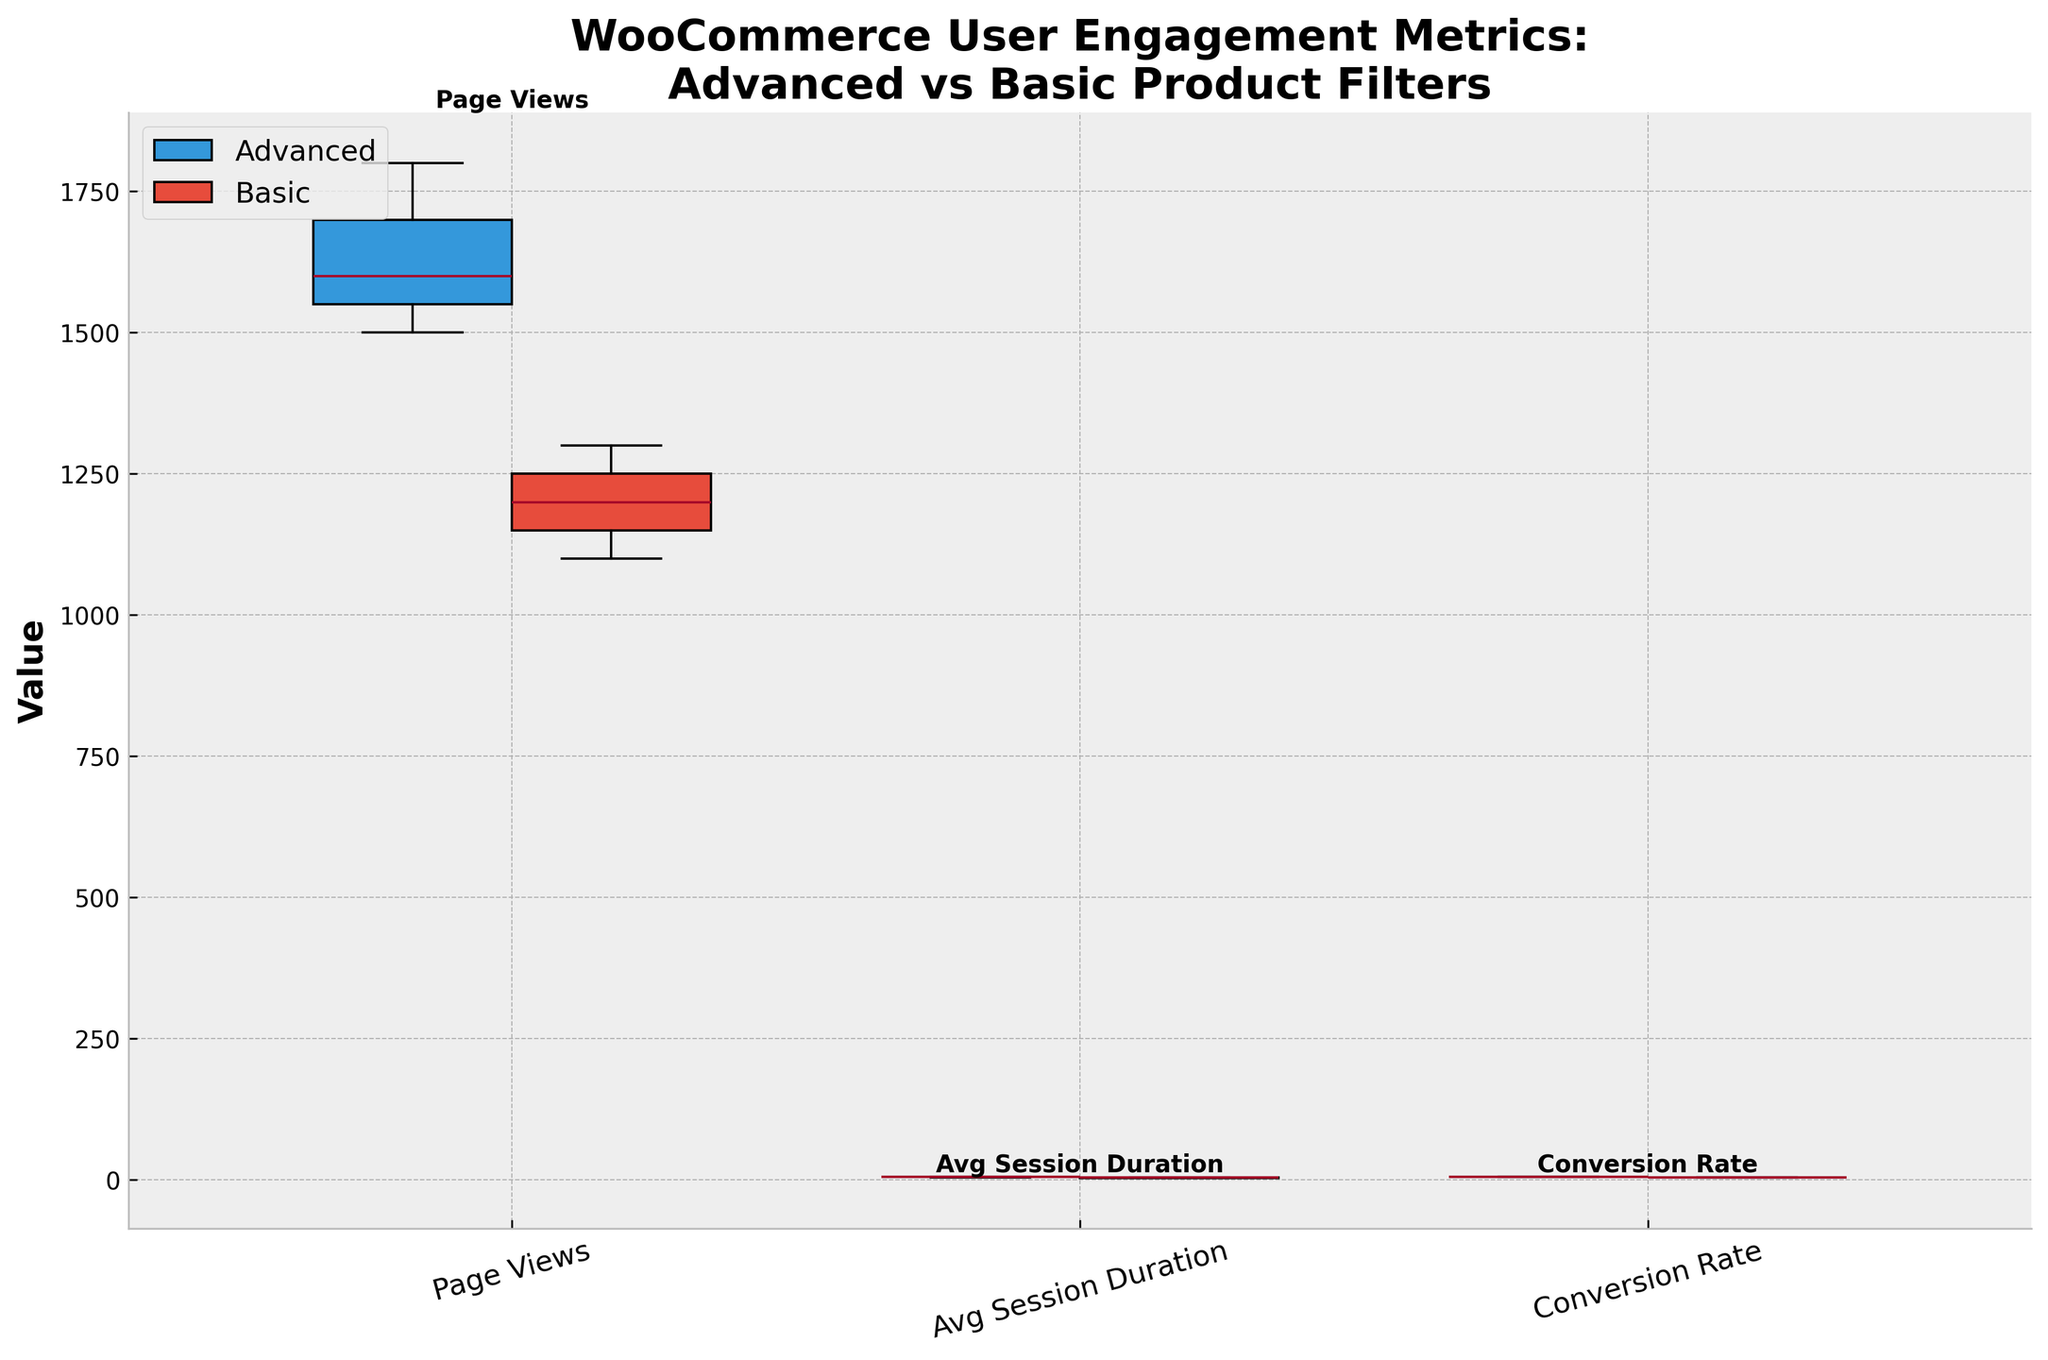What are the titles of the x-axis and y-axis in the plot? The x-axis title represents various user engagement metrics, which are "Page Views," "Avg Session Duration," and "Conversion Rate." The y-axis title represents the "Value" of these metrics.
Answer: x-axis: Metrics; y-axis: Value What colors represent the 'Advanced' and 'Basic' filter types in the plot? The 'Advanced' filter type is represented by blue-colored boxes, and the 'Basic' filter type is represented by red-colored boxes.
Answer: Advanced: Blue, Basic: Red Which filter type has a higher median page view value? The median page view value for each filter type can be assessed by looking at the mid-line in the boxes under the "Page Views" metric. The blue box (Advanced) has a higher median page view value than the red box (Basic).
Answer: Advanced What is the approximate range for average session duration for stores using advanced filters? The approximate range is determined by looking at the bottom (minimum) and top (maximum) of the box representing "Avg Session Duration" under the blue (Advanced) box. The range is approximately from 4.5 to 5.0.
Answer: 4.5 to 5.0 Compare the spread of the conversion rate between the advanced and basic filters. Which has a wider range? The spread for each filter type can be determined by comparing the length of the boxes for "Conversion Rate." The red box (Basic) appears to have a wider spread than the blue box (Advanced), indicating a wider range for conversion rate.
Answer: Basic Which metric shows the most noticeable difference in medians between the advanced and basic filter types? By comparing the mid-lines (medians) of the boxes for each metric, "Page Views" shows the most noticeable difference in medians between the blue (Advanced) and red (Basic) boxes.
Answer: Page Views Are there any outliers visible in the conversion rate for either filter type? Outliers in a box plot would be indicated by points outside the whiskers of the boxes. There are no visible outliers for conversion rates in either the blue (Advanced) or red (Basic) boxes.
Answer: No For which engagement metric does the use of advanced filters consistently yield higher values across all stores compared to basic filters? By observing the positions of the blue and red boxes for each metric, it's evident that "Page Views," "Avg Session Duration," and "Conversion Rate" all have consistently higher values in the blue boxes (Advanced) compared to the red boxes (Basic).
Answer: All metrics What is the title of the plot? The title at the top of the plot indicates the comparison being made, which is "WooCommerce User Engagement Metrics: Advanced vs Basic Product Filters."
Answer: WooCommerce User Engagement Metrics: Advanced vs Basic Product Filters How do the variances of average session duration compare between advanced and basic filters? The variance can be visually assessed by looking at the height of the boxes and the length of the whiskers. The blue (Advanced) box for "Avg Session Duration" appears to have less variance due to its shorter height and whiskers compared to the red (Basic) box.
Answer: Advanced has less variance 